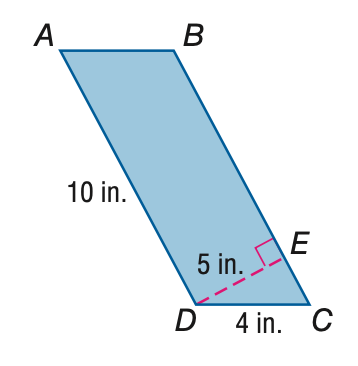Question: Find the area of \parallelogram A B C D.
Choices:
A. 30
B. 40
C. 50
D. 60
Answer with the letter. Answer: C Question: Find the perimeter of \parallelogram A B C D.
Choices:
A. 20
B. 24
C. 28
D. 32
Answer with the letter. Answer: C 